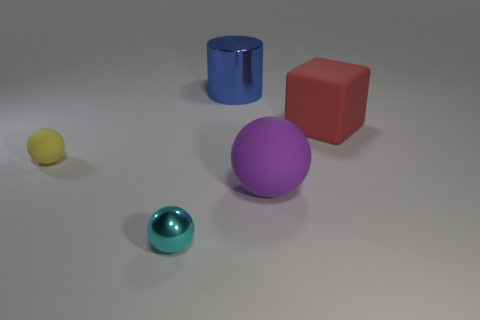Is the number of large red shiny balls less than the number of large cubes?
Your answer should be compact. Yes. There is a matte object that is both right of the big blue shiny cylinder and left of the red rubber block; how big is it?
Make the answer very short. Large. Is the number of large red things on the left side of the big red cube less than the number of tiny yellow matte objects?
Give a very brief answer. Yes. The large purple thing that is made of the same material as the large red cube is what shape?
Provide a short and direct response. Sphere. Is the tiny cyan sphere made of the same material as the block?
Your answer should be compact. No. Are there fewer things that are to the left of the tiny yellow matte object than big metallic things that are on the right side of the red matte block?
Keep it short and to the point. No. There is a tiny thing that is behind the object that is in front of the purple matte thing; how many large red matte objects are behind it?
Give a very brief answer. 1. Does the large cube have the same color as the big cylinder?
Offer a very short reply. No. There is a rubber sphere that is the same size as the blue thing; what color is it?
Ensure brevity in your answer.  Purple. Is there a red matte thing that has the same shape as the cyan object?
Your answer should be compact. No. 